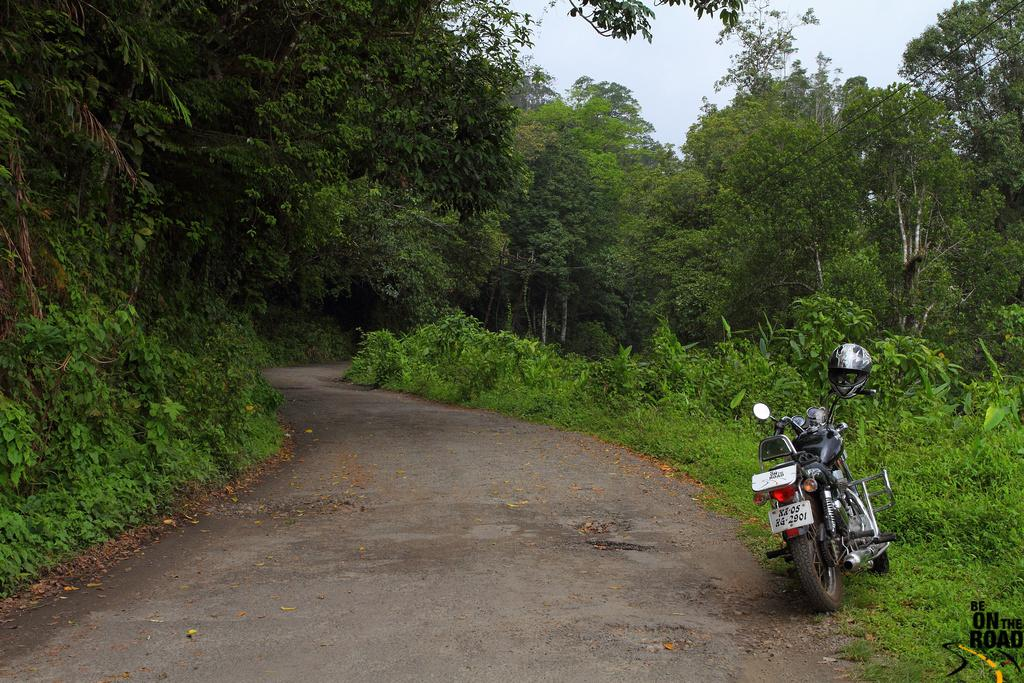What is the main object in the image? There is a bike in the image. What type of terrain is visible in the image? There is grass and a road in the image. What other natural elements can be seen in the image? There are plants and trees in the image. What is visible in the background of the image? The sky is visible in the background of the image. Can you describe any additional features of the image? There is a watermark at the bottom of the picture. How many people are using the bike for support in the image? There are no people using the bike for support in the image, as it is the main object and not being used by anyone. What type of seat is attached to the bike in the image? There is no seat attached to the bike in the image, as it is a bicycle and typically does not have a seat. 